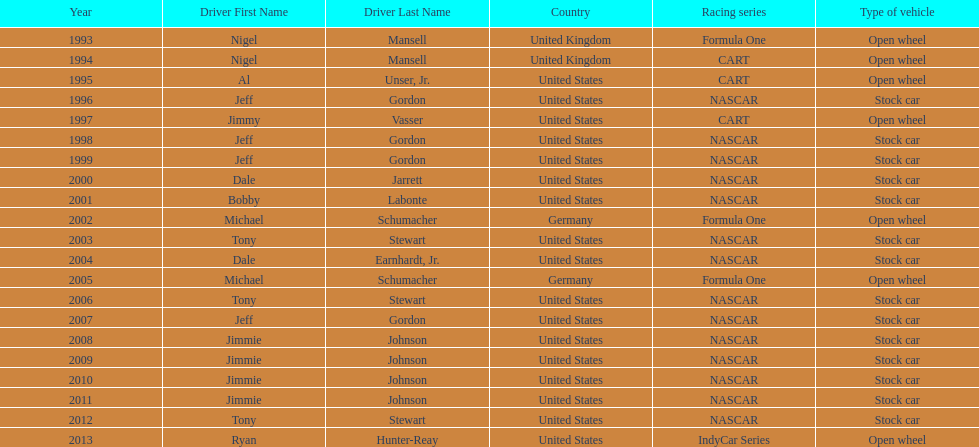I'm looking to parse the entire table for insights. Could you assist me with that? {'header': ['Year', 'Driver First Name', 'Driver Last Name', 'Country', 'Racing series', 'Type of vehicle'], 'rows': [['1993', 'Nigel', 'Mansell', 'United Kingdom', 'Formula One', 'Open wheel'], ['1994', 'Nigel', 'Mansell', 'United Kingdom', 'CART', 'Open wheel'], ['1995', 'Al', 'Unser, Jr.', 'United States', 'CART', 'Open wheel'], ['1996', 'Jeff', 'Gordon', 'United States', 'NASCAR', 'Stock car'], ['1997', 'Jimmy', 'Vasser', 'United States', 'CART', 'Open wheel'], ['1998', 'Jeff', 'Gordon', 'United States', 'NASCAR', 'Stock car'], ['1999', 'Jeff', 'Gordon', 'United States', 'NASCAR', 'Stock car'], ['2000', 'Dale', 'Jarrett', 'United States', 'NASCAR', 'Stock car'], ['2001', 'Bobby', 'Labonte', 'United States', 'NASCAR', 'Stock car'], ['2002', 'Michael', 'Schumacher', 'Germany', 'Formula One', 'Open wheel'], ['2003', 'Tony', 'Stewart', 'United States', 'NASCAR', 'Stock car'], ['2004', 'Dale', 'Earnhardt, Jr.', 'United States', 'NASCAR', 'Stock car'], ['2005', 'Michael', 'Schumacher', 'Germany', 'Formula One', 'Open wheel'], ['2006', 'Tony', 'Stewart', 'United States', 'NASCAR', 'Stock car'], ['2007', 'Jeff', 'Gordon', 'United States', 'NASCAR', 'Stock car'], ['2008', 'Jimmie', 'Johnson', 'United States', 'NASCAR', 'Stock car'], ['2009', 'Jimmie', 'Johnson', 'United States', 'NASCAR', 'Stock car'], ['2010', 'Jimmie', 'Johnson', 'United States', 'NASCAR', 'Stock car'], ['2011', 'Jimmie', 'Johnson', 'United States', 'NASCAR', 'Stock car'], ['2012', 'Tony', 'Stewart', 'United States', 'NASCAR', 'Stock car'], ['2013', 'Ryan', 'Hunter-Reay', 'United States', 'IndyCar Series', 'Open wheel']]} How many total row entries are there? 21. 